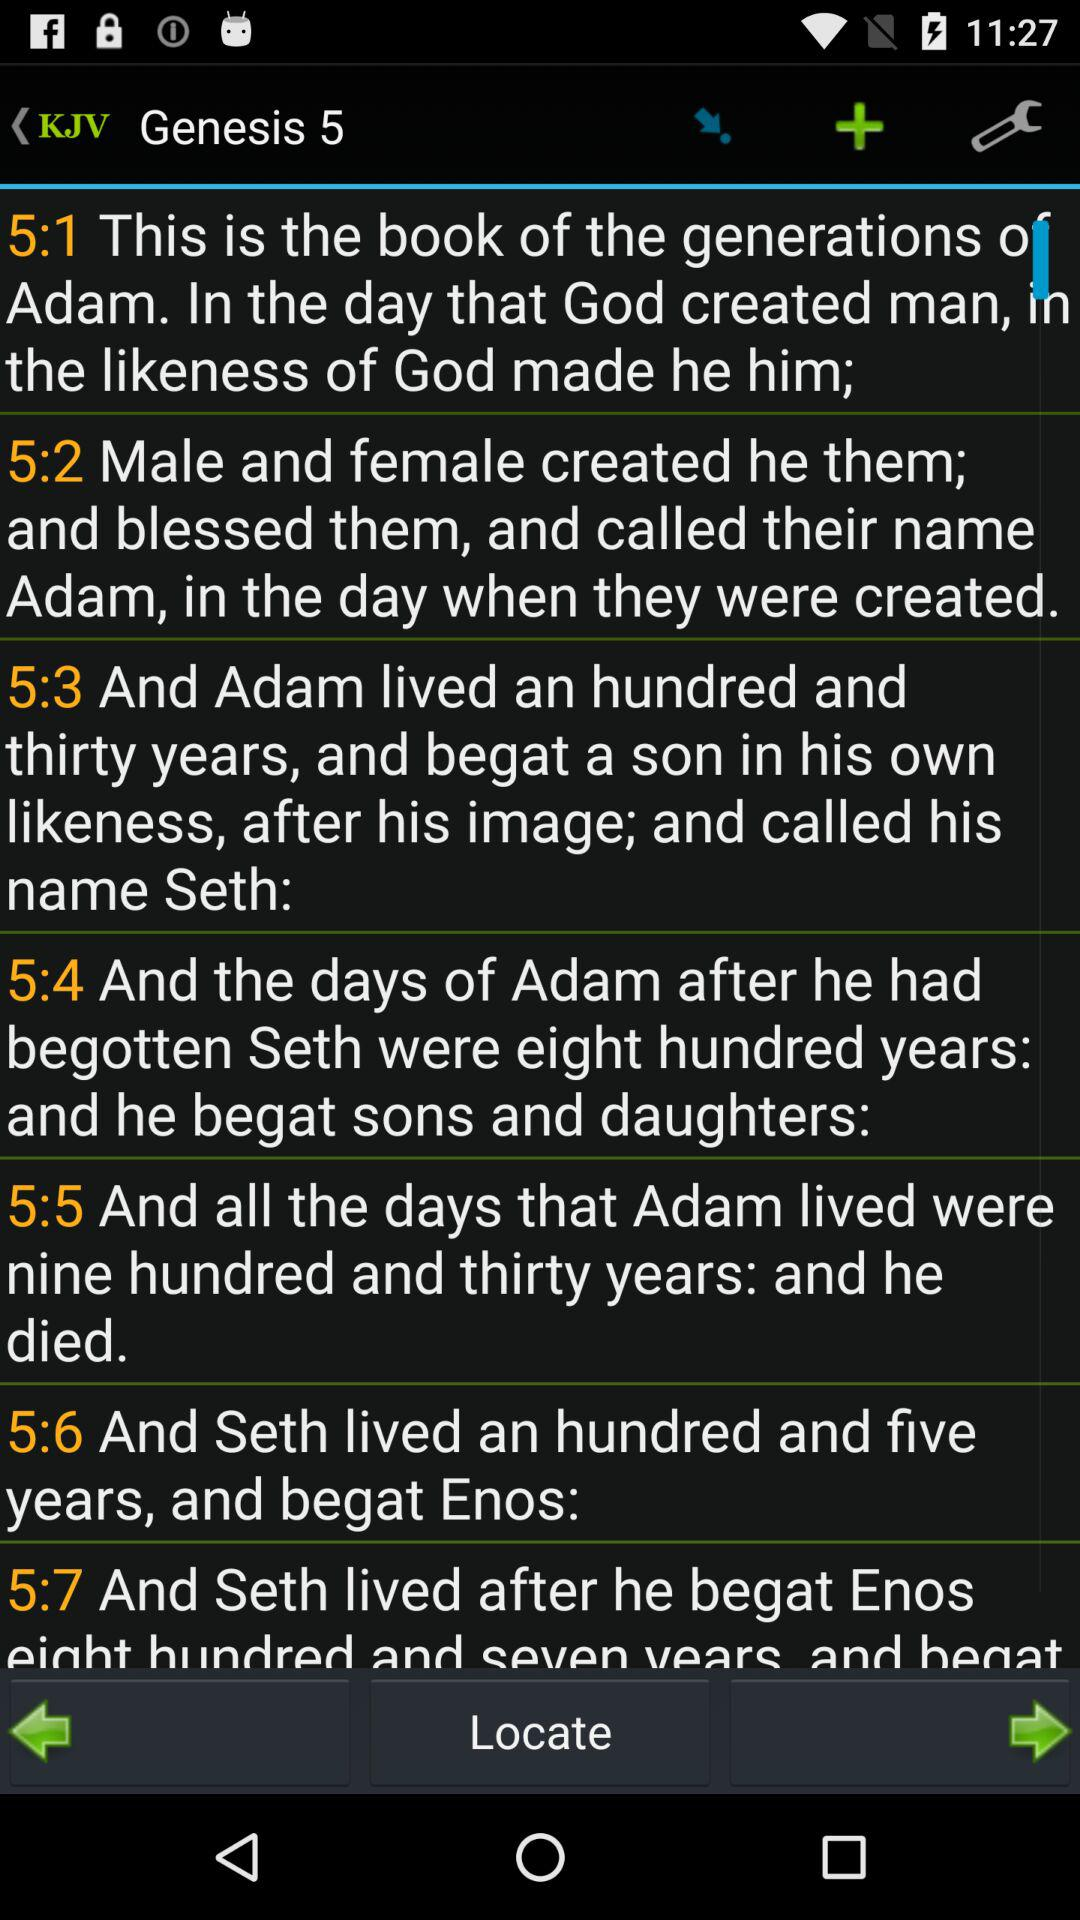How many years did Seth live after begetting Enos?
Answer the question using a single word or phrase. 807 